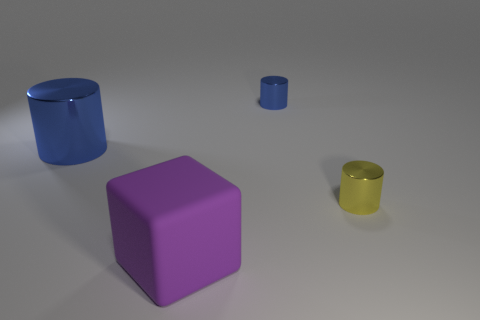Subtract all yellow cylinders. How many cylinders are left? 2 Add 2 blue cylinders. How many objects exist? 6 Subtract all cylinders. How many objects are left? 1 Subtract all yellow cylinders. How many cylinders are left? 2 Subtract 0 purple spheres. How many objects are left? 4 Subtract 1 cylinders. How many cylinders are left? 2 Subtract all red cylinders. Subtract all blue balls. How many cylinders are left? 3 Subtract all purple cylinders. How many gray blocks are left? 0 Subtract all large cyan matte blocks. Subtract all large purple blocks. How many objects are left? 3 Add 3 purple matte things. How many purple matte things are left? 4 